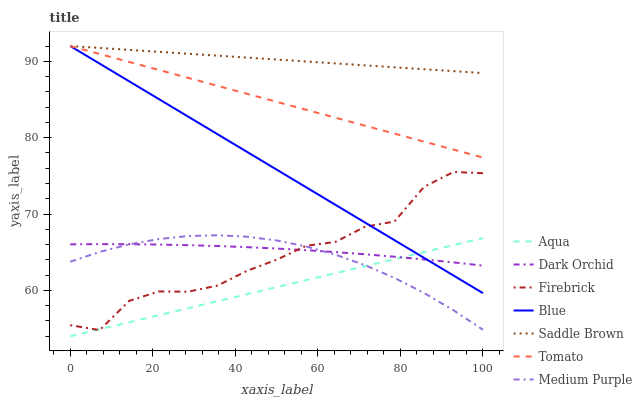Does Aqua have the minimum area under the curve?
Answer yes or no. Yes. Does Saddle Brown have the maximum area under the curve?
Answer yes or no. Yes. Does Tomato have the minimum area under the curve?
Answer yes or no. No. Does Tomato have the maximum area under the curve?
Answer yes or no. No. Is Aqua the smoothest?
Answer yes or no. Yes. Is Firebrick the roughest?
Answer yes or no. Yes. Is Tomato the smoothest?
Answer yes or no. No. Is Tomato the roughest?
Answer yes or no. No. Does Tomato have the lowest value?
Answer yes or no. No. Does Saddle Brown have the highest value?
Answer yes or no. Yes. Does Firebrick have the highest value?
Answer yes or no. No. Is Firebrick less than Tomato?
Answer yes or no. Yes. Is Saddle Brown greater than Aqua?
Answer yes or no. Yes. Does Firebrick intersect Medium Purple?
Answer yes or no. Yes. Is Firebrick less than Medium Purple?
Answer yes or no. No. Is Firebrick greater than Medium Purple?
Answer yes or no. No. Does Firebrick intersect Tomato?
Answer yes or no. No. 